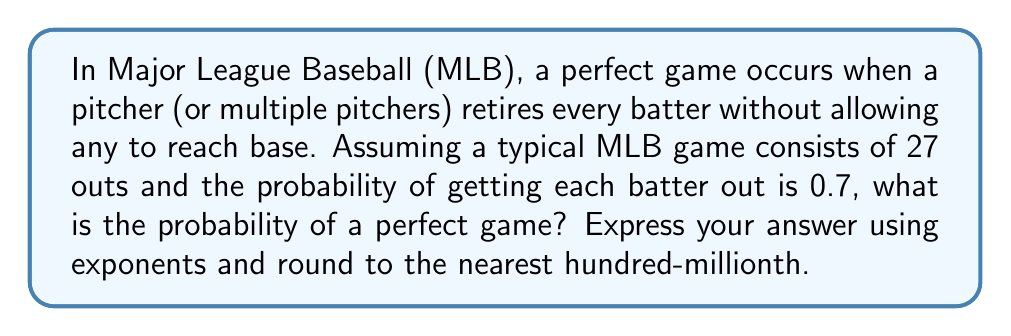Give your solution to this math problem. Let's approach this step-by-step:

1) In a perfect game, all 27 batters must be retired without reaching base.

2) The probability of getting each batter out is given as 0.7.

3) For a perfect game, this needs to happen 27 times in a row.

4) When we have independent events that all need to occur, we multiply the individual probabilities.

5) Therefore, the probability of a perfect game is:

   $$(0.7)^{27}$$

6) Let's calculate this:

   $$(0.7)^{27} \approx 0.0000000982$$

7) Rounding to the nearest hundred-millionth:

   $$(0.7)^{27} \approx 0.00000010$$
Answer: $1 \times 10^{-7}$ 